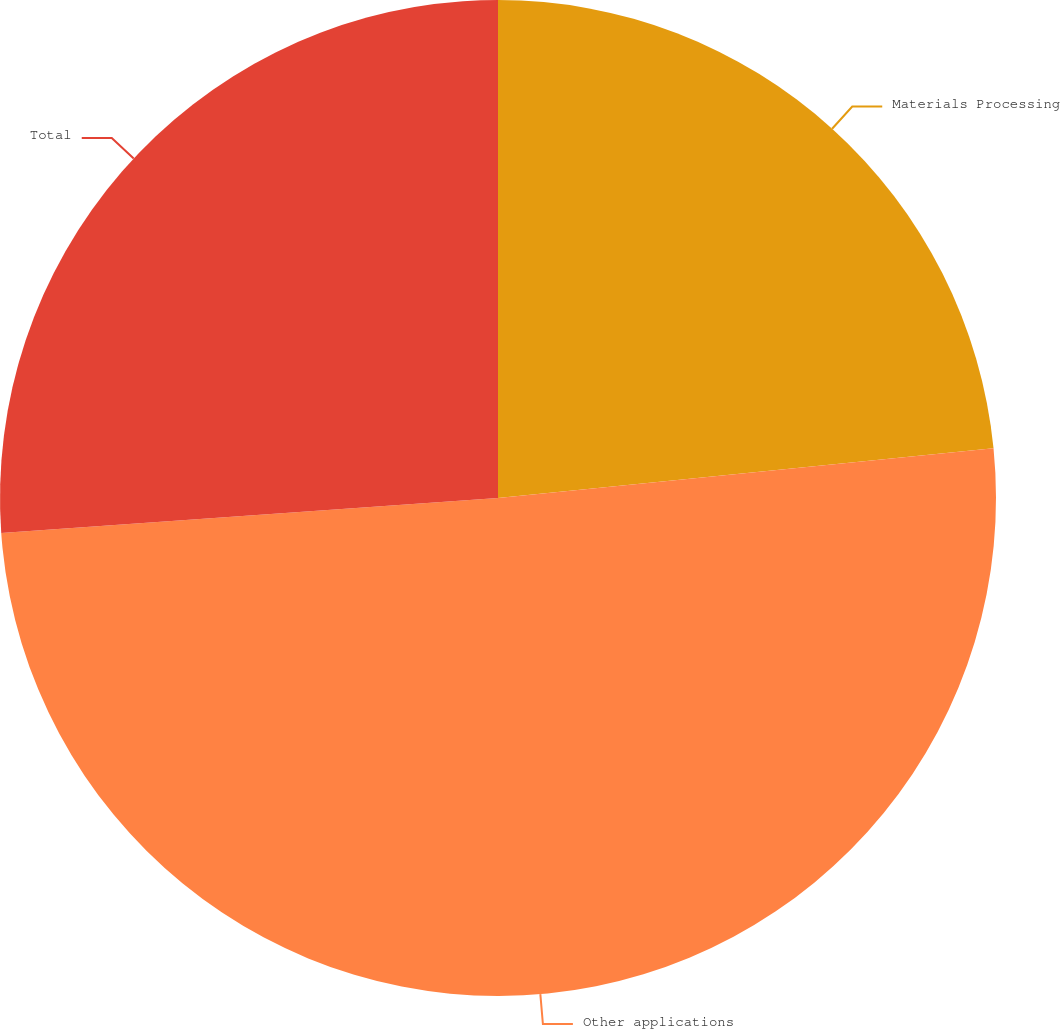Convert chart to OTSL. <chart><loc_0><loc_0><loc_500><loc_500><pie_chart><fcel>Materials Processing<fcel>Other applications<fcel>Total<nl><fcel>23.41%<fcel>50.47%<fcel>26.12%<nl></chart> 